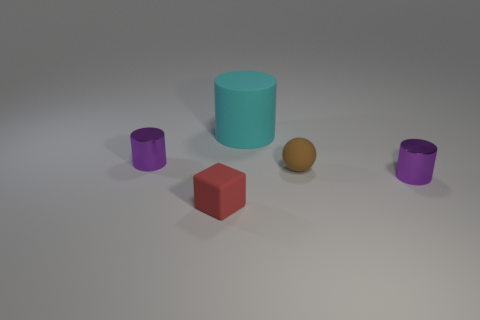There is a tiny metallic object on the left side of the matte block; is its shape the same as the cyan matte thing?
Offer a terse response. Yes. What number of objects are either small purple metallic things that are left of the red matte cube or tiny purple shiny cylinders that are to the left of the tiny red matte thing?
Your answer should be compact. 1. Does the large cylinder have the same color as the tiny rubber block that is to the left of the big cylinder?
Offer a terse response. No. The big cyan object that is made of the same material as the brown ball is what shape?
Offer a very short reply. Cylinder. How many small metal cylinders are there?
Ensure brevity in your answer.  2. What number of things are tiny purple shiny things that are on the right side of the tiny cube or small cyan things?
Your answer should be compact. 1. Is the color of the small metallic thing to the right of the large cyan thing the same as the tiny cube?
Give a very brief answer. No. How many other things are there of the same color as the rubber cylinder?
Your answer should be compact. 0. What number of tiny things are either metallic spheres or metal cylinders?
Your answer should be compact. 2. Is the number of red cylinders greater than the number of purple shiny cylinders?
Offer a very short reply. No. 